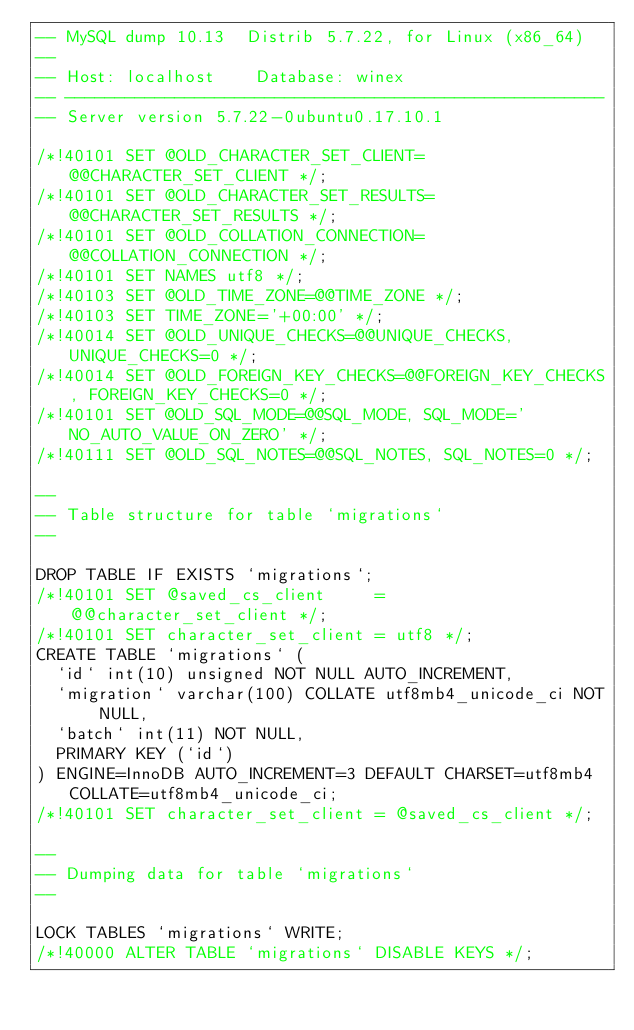Convert code to text. <code><loc_0><loc_0><loc_500><loc_500><_SQL_>-- MySQL dump 10.13  Distrib 5.7.22, for Linux (x86_64)
--
-- Host: localhost    Database: winex
-- ------------------------------------------------------
-- Server version	5.7.22-0ubuntu0.17.10.1

/*!40101 SET @OLD_CHARACTER_SET_CLIENT=@@CHARACTER_SET_CLIENT */;
/*!40101 SET @OLD_CHARACTER_SET_RESULTS=@@CHARACTER_SET_RESULTS */;
/*!40101 SET @OLD_COLLATION_CONNECTION=@@COLLATION_CONNECTION */;
/*!40101 SET NAMES utf8 */;
/*!40103 SET @OLD_TIME_ZONE=@@TIME_ZONE */;
/*!40103 SET TIME_ZONE='+00:00' */;
/*!40014 SET @OLD_UNIQUE_CHECKS=@@UNIQUE_CHECKS, UNIQUE_CHECKS=0 */;
/*!40014 SET @OLD_FOREIGN_KEY_CHECKS=@@FOREIGN_KEY_CHECKS, FOREIGN_KEY_CHECKS=0 */;
/*!40101 SET @OLD_SQL_MODE=@@SQL_MODE, SQL_MODE='NO_AUTO_VALUE_ON_ZERO' */;
/*!40111 SET @OLD_SQL_NOTES=@@SQL_NOTES, SQL_NOTES=0 */;

--
-- Table structure for table `migrations`
--

DROP TABLE IF EXISTS `migrations`;
/*!40101 SET @saved_cs_client     = @@character_set_client */;
/*!40101 SET character_set_client = utf8 */;
CREATE TABLE `migrations` (
  `id` int(10) unsigned NOT NULL AUTO_INCREMENT,
  `migration` varchar(100) COLLATE utf8mb4_unicode_ci NOT NULL,
  `batch` int(11) NOT NULL,
  PRIMARY KEY (`id`)
) ENGINE=InnoDB AUTO_INCREMENT=3 DEFAULT CHARSET=utf8mb4 COLLATE=utf8mb4_unicode_ci;
/*!40101 SET character_set_client = @saved_cs_client */;

--
-- Dumping data for table `migrations`
--

LOCK TABLES `migrations` WRITE;
/*!40000 ALTER TABLE `migrations` DISABLE KEYS */;</code> 